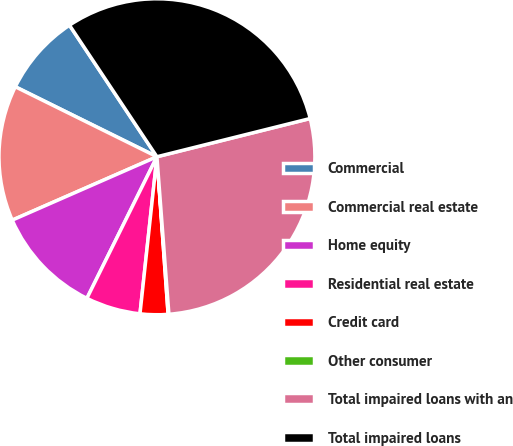Convert chart. <chart><loc_0><loc_0><loc_500><loc_500><pie_chart><fcel>Commercial<fcel>Commercial real estate<fcel>Home equity<fcel>Residential real estate<fcel>Credit card<fcel>Other consumer<fcel>Total impaired loans with an<fcel>Total impaired loans<nl><fcel>8.36%<fcel>13.88%<fcel>11.12%<fcel>5.6%<fcel>2.84%<fcel>0.08%<fcel>27.69%<fcel>30.45%<nl></chart> 